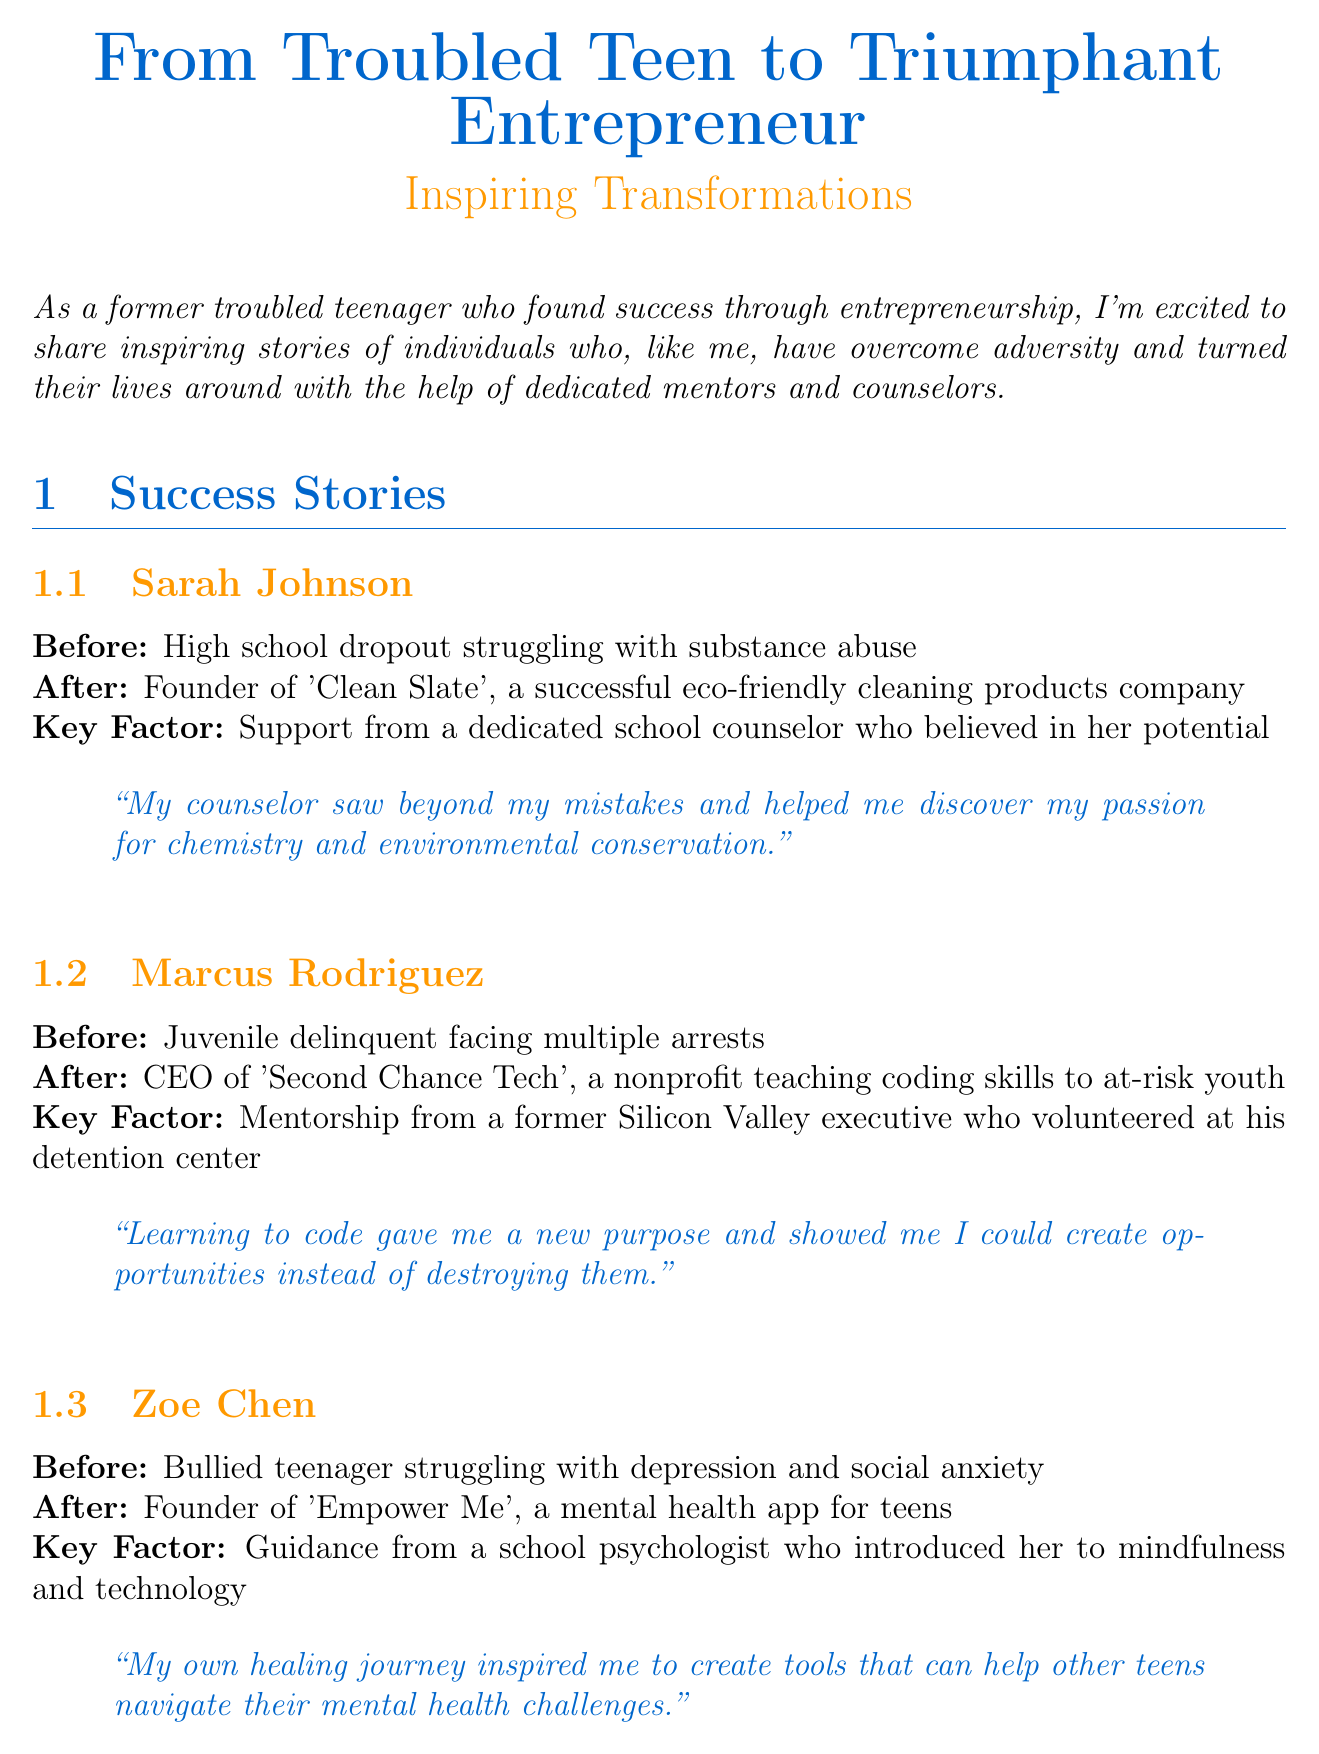What is the title of the newsletter? The title of the newsletter is stated at the beginning of the document.
Answer: From Troubled Teen to Triumphant Entrepreneur: Inspiring Transformations Who is the first success story featured? The first success story listed in the document is under the section "Success Stories."
Answer: Sarah Johnson What was Marcus Rodriguez's before situation? Marcus Rodriguez's situation before transformation is mentioned in his section.
Answer: Juvenile delinquent facing multiple arrests What is the name of Zoe Chen's founded app? The name of the app created by Zoe Chen is indicated in her success story.
Answer: Empower Me What is a key factor in Sarah Johnson's transformation? Each success story includes a key factor that contributed to the individual's success, such as support from mentors.
Answer: Support from a dedicated school counselor who believed in her potential Who provided mentorship to Marcus Rodriguez? The document specifies who provided guidance to Marcus Rodriguez during his transformation.
Answer: A former Silicon Valley executive What type of resource is the National Mentoring Resource Center? The document classifies the resources available at the end, including the National Mentoring Resource Center.
Answer: Provides resources and research on effective mentoring programs What does Dr. Emily Foster emphasize as crucial for transformation? Dr. Foster's insights include key points about the transformation process, highlighting important elements.
Answer: Early intervention How many success stories are featured in the newsletter? The document clearly states the number of success stories included in the success stories section.
Answer: Three 